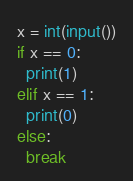Convert code to text. <code><loc_0><loc_0><loc_500><loc_500><_Python_>x = int(input())
if x == 0:
  print(1)
elif x == 1:
  print(0)
else:
  break</code> 